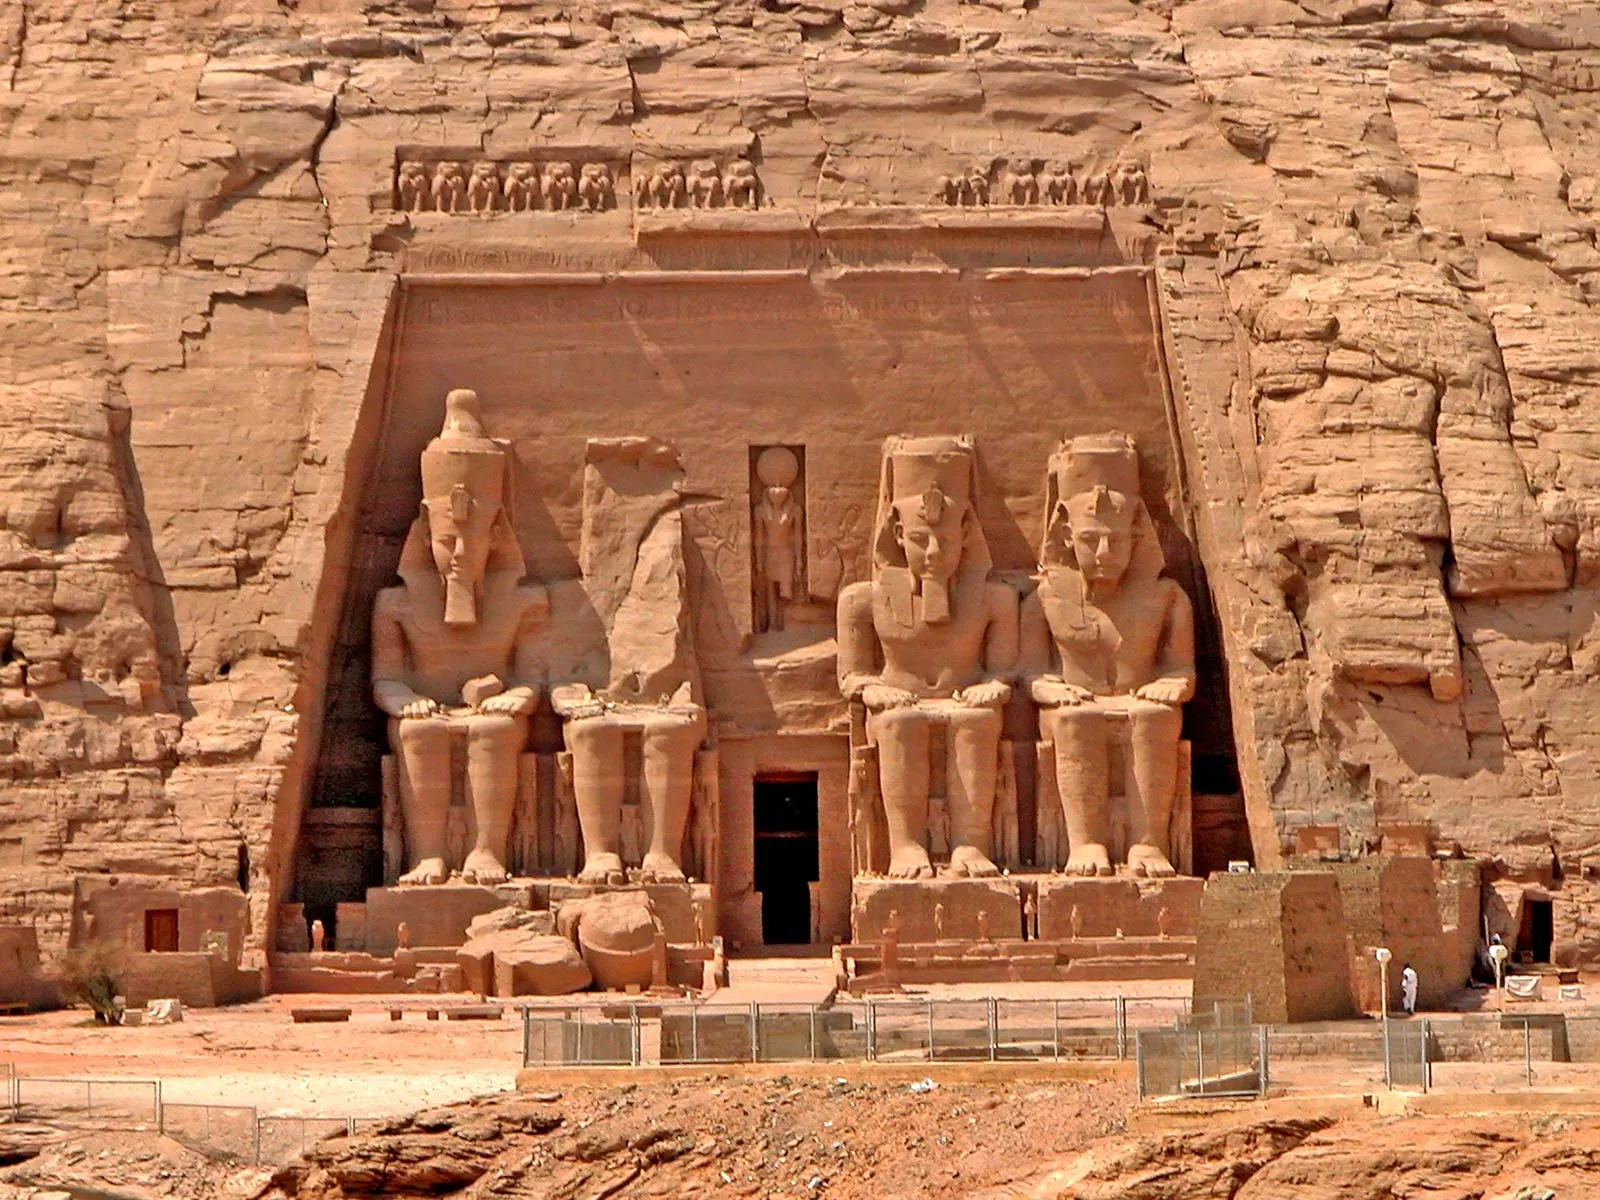Can you describe the architectural style and elements seen in the temple's facade? The architectural style of Abu Simbel is a prime example of ancient Egyptian rock-cut temple design, characterized by its grand scale and elaborate facade. The temple is hewn into a sandstone cliff and features a dominating facade with four colossal statues of Pharaoh Ramesses II seated on thrones. Each figure is symmetrically posed, exuding a sense of order and power. Above the entrance, there is a row of 22 baboons, worshipping the rising sun, adding a symbolic layer to the architectural narrative. The facade is also decorated with hieroglyphic inscriptions and bas-relief figures that highlight religious and cultural motifs, integral to the structure’s purpose as a sacred site. 